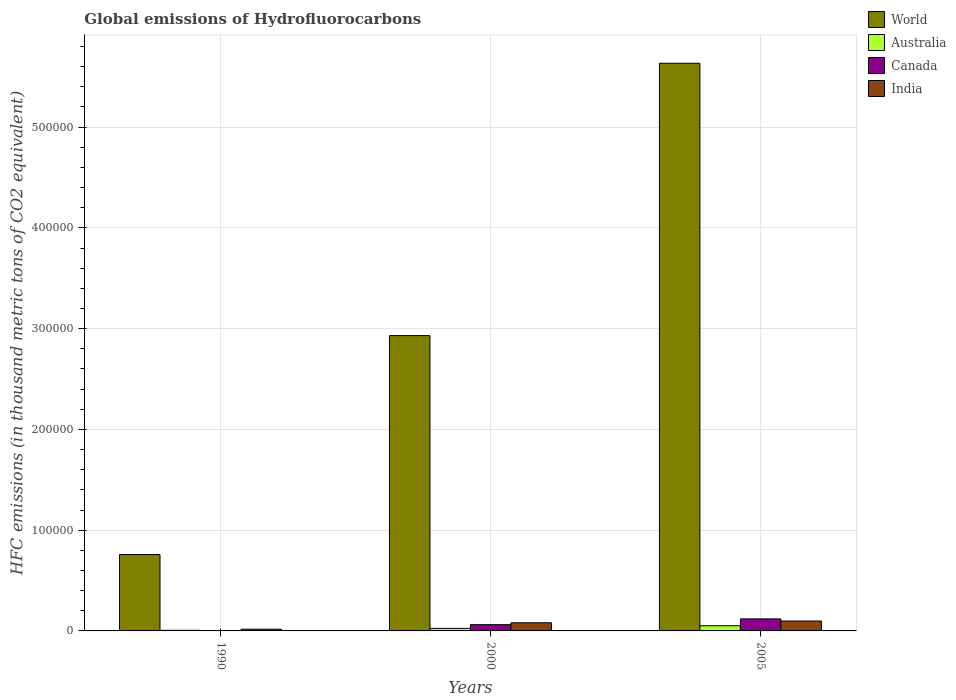How many different coloured bars are there?
Ensure brevity in your answer.  4. Are the number of bars on each tick of the X-axis equal?
Your answer should be very brief. Yes. What is the label of the 1st group of bars from the left?
Your answer should be very brief. 1990. In how many cases, is the number of bars for a given year not equal to the number of legend labels?
Give a very brief answer. 0. What is the global emissions of Hydrofluorocarbons in Canada in 1990?
Your answer should be very brief. 418.5. Across all years, what is the maximum global emissions of Hydrofluorocarbons in World?
Your answer should be compact. 5.63e+05. Across all years, what is the minimum global emissions of Hydrofluorocarbons in Canada?
Your answer should be very brief. 418.5. What is the total global emissions of Hydrofluorocarbons in World in the graph?
Ensure brevity in your answer.  9.32e+05. What is the difference between the global emissions of Hydrofluorocarbons in World in 1990 and that in 2005?
Ensure brevity in your answer.  -4.88e+05. What is the difference between the global emissions of Hydrofluorocarbons in India in 2000 and the global emissions of Hydrofluorocarbons in Canada in 2005?
Provide a short and direct response. -3821.2. What is the average global emissions of Hydrofluorocarbons in Canada per year?
Make the answer very short. 6183.23. In the year 1990, what is the difference between the global emissions of Hydrofluorocarbons in World and global emissions of Hydrofluorocarbons in Australia?
Provide a short and direct response. 7.52e+04. What is the ratio of the global emissions of Hydrofluorocarbons in India in 2000 to that in 2005?
Your response must be concise. 0.82. Is the global emissions of Hydrofluorocarbons in India in 2000 less than that in 2005?
Make the answer very short. Yes. Is the difference between the global emissions of Hydrofluorocarbons in World in 2000 and 2005 greater than the difference between the global emissions of Hydrofluorocarbons in Australia in 2000 and 2005?
Give a very brief answer. No. What is the difference between the highest and the second highest global emissions of Hydrofluorocarbons in India?
Offer a very short reply. 1738. What is the difference between the highest and the lowest global emissions of Hydrofluorocarbons in Australia?
Keep it short and to the point. 4533.1. In how many years, is the global emissions of Hydrofluorocarbons in Canada greater than the average global emissions of Hydrofluorocarbons in Canada taken over all years?
Your answer should be compact. 2. Are all the bars in the graph horizontal?
Your answer should be very brief. No. How many years are there in the graph?
Your answer should be compact. 3. Are the values on the major ticks of Y-axis written in scientific E-notation?
Provide a succinct answer. No. Does the graph contain any zero values?
Give a very brief answer. No. Does the graph contain grids?
Your answer should be very brief. Yes. How are the legend labels stacked?
Offer a terse response. Vertical. What is the title of the graph?
Make the answer very short. Global emissions of Hydrofluorocarbons. What is the label or title of the X-axis?
Give a very brief answer. Years. What is the label or title of the Y-axis?
Ensure brevity in your answer.  HFC emissions (in thousand metric tons of CO2 equivalent). What is the HFC emissions (in thousand metric tons of CO2 equivalent) of World in 1990?
Offer a terse response. 7.58e+04. What is the HFC emissions (in thousand metric tons of CO2 equivalent) in Australia in 1990?
Your answer should be compact. 612.5. What is the HFC emissions (in thousand metric tons of CO2 equivalent) in Canada in 1990?
Ensure brevity in your answer.  418.5. What is the HFC emissions (in thousand metric tons of CO2 equivalent) of India in 1990?
Provide a succinct answer. 1702.1. What is the HFC emissions (in thousand metric tons of CO2 equivalent) in World in 2000?
Offer a very short reply. 2.93e+05. What is the HFC emissions (in thousand metric tons of CO2 equivalent) of Australia in 2000?
Ensure brevity in your answer.  2545.7. What is the HFC emissions (in thousand metric tons of CO2 equivalent) of Canada in 2000?
Your answer should be compact. 6202.8. What is the HFC emissions (in thousand metric tons of CO2 equivalent) of India in 2000?
Offer a terse response. 8107.2. What is the HFC emissions (in thousand metric tons of CO2 equivalent) in World in 2005?
Your response must be concise. 5.63e+05. What is the HFC emissions (in thousand metric tons of CO2 equivalent) of Australia in 2005?
Your answer should be very brief. 5145.6. What is the HFC emissions (in thousand metric tons of CO2 equivalent) in Canada in 2005?
Your answer should be compact. 1.19e+04. What is the HFC emissions (in thousand metric tons of CO2 equivalent) of India in 2005?
Make the answer very short. 9845.2. Across all years, what is the maximum HFC emissions (in thousand metric tons of CO2 equivalent) of World?
Your answer should be compact. 5.63e+05. Across all years, what is the maximum HFC emissions (in thousand metric tons of CO2 equivalent) of Australia?
Provide a succinct answer. 5145.6. Across all years, what is the maximum HFC emissions (in thousand metric tons of CO2 equivalent) in Canada?
Make the answer very short. 1.19e+04. Across all years, what is the maximum HFC emissions (in thousand metric tons of CO2 equivalent) in India?
Make the answer very short. 9845.2. Across all years, what is the minimum HFC emissions (in thousand metric tons of CO2 equivalent) in World?
Your answer should be compact. 7.58e+04. Across all years, what is the minimum HFC emissions (in thousand metric tons of CO2 equivalent) of Australia?
Offer a very short reply. 612.5. Across all years, what is the minimum HFC emissions (in thousand metric tons of CO2 equivalent) of Canada?
Offer a very short reply. 418.5. Across all years, what is the minimum HFC emissions (in thousand metric tons of CO2 equivalent) of India?
Provide a succinct answer. 1702.1. What is the total HFC emissions (in thousand metric tons of CO2 equivalent) of World in the graph?
Offer a terse response. 9.32e+05. What is the total HFC emissions (in thousand metric tons of CO2 equivalent) in Australia in the graph?
Provide a succinct answer. 8303.8. What is the total HFC emissions (in thousand metric tons of CO2 equivalent) in Canada in the graph?
Keep it short and to the point. 1.85e+04. What is the total HFC emissions (in thousand metric tons of CO2 equivalent) in India in the graph?
Provide a succinct answer. 1.97e+04. What is the difference between the HFC emissions (in thousand metric tons of CO2 equivalent) in World in 1990 and that in 2000?
Give a very brief answer. -2.17e+05. What is the difference between the HFC emissions (in thousand metric tons of CO2 equivalent) of Australia in 1990 and that in 2000?
Offer a terse response. -1933.2. What is the difference between the HFC emissions (in thousand metric tons of CO2 equivalent) of Canada in 1990 and that in 2000?
Keep it short and to the point. -5784.3. What is the difference between the HFC emissions (in thousand metric tons of CO2 equivalent) in India in 1990 and that in 2000?
Give a very brief answer. -6405.1. What is the difference between the HFC emissions (in thousand metric tons of CO2 equivalent) in World in 1990 and that in 2005?
Give a very brief answer. -4.88e+05. What is the difference between the HFC emissions (in thousand metric tons of CO2 equivalent) of Australia in 1990 and that in 2005?
Make the answer very short. -4533.1. What is the difference between the HFC emissions (in thousand metric tons of CO2 equivalent) of Canada in 1990 and that in 2005?
Keep it short and to the point. -1.15e+04. What is the difference between the HFC emissions (in thousand metric tons of CO2 equivalent) in India in 1990 and that in 2005?
Keep it short and to the point. -8143.1. What is the difference between the HFC emissions (in thousand metric tons of CO2 equivalent) of World in 2000 and that in 2005?
Your response must be concise. -2.70e+05. What is the difference between the HFC emissions (in thousand metric tons of CO2 equivalent) in Australia in 2000 and that in 2005?
Give a very brief answer. -2599.9. What is the difference between the HFC emissions (in thousand metric tons of CO2 equivalent) in Canada in 2000 and that in 2005?
Keep it short and to the point. -5725.6. What is the difference between the HFC emissions (in thousand metric tons of CO2 equivalent) of India in 2000 and that in 2005?
Offer a very short reply. -1738. What is the difference between the HFC emissions (in thousand metric tons of CO2 equivalent) of World in 1990 and the HFC emissions (in thousand metric tons of CO2 equivalent) of Australia in 2000?
Your response must be concise. 7.33e+04. What is the difference between the HFC emissions (in thousand metric tons of CO2 equivalent) in World in 1990 and the HFC emissions (in thousand metric tons of CO2 equivalent) in Canada in 2000?
Offer a terse response. 6.96e+04. What is the difference between the HFC emissions (in thousand metric tons of CO2 equivalent) in World in 1990 and the HFC emissions (in thousand metric tons of CO2 equivalent) in India in 2000?
Offer a terse response. 6.77e+04. What is the difference between the HFC emissions (in thousand metric tons of CO2 equivalent) in Australia in 1990 and the HFC emissions (in thousand metric tons of CO2 equivalent) in Canada in 2000?
Your answer should be very brief. -5590.3. What is the difference between the HFC emissions (in thousand metric tons of CO2 equivalent) of Australia in 1990 and the HFC emissions (in thousand metric tons of CO2 equivalent) of India in 2000?
Keep it short and to the point. -7494.7. What is the difference between the HFC emissions (in thousand metric tons of CO2 equivalent) in Canada in 1990 and the HFC emissions (in thousand metric tons of CO2 equivalent) in India in 2000?
Make the answer very short. -7688.7. What is the difference between the HFC emissions (in thousand metric tons of CO2 equivalent) in World in 1990 and the HFC emissions (in thousand metric tons of CO2 equivalent) in Australia in 2005?
Keep it short and to the point. 7.07e+04. What is the difference between the HFC emissions (in thousand metric tons of CO2 equivalent) of World in 1990 and the HFC emissions (in thousand metric tons of CO2 equivalent) of Canada in 2005?
Make the answer very short. 6.39e+04. What is the difference between the HFC emissions (in thousand metric tons of CO2 equivalent) of World in 1990 and the HFC emissions (in thousand metric tons of CO2 equivalent) of India in 2005?
Provide a short and direct response. 6.60e+04. What is the difference between the HFC emissions (in thousand metric tons of CO2 equivalent) of Australia in 1990 and the HFC emissions (in thousand metric tons of CO2 equivalent) of Canada in 2005?
Your answer should be very brief. -1.13e+04. What is the difference between the HFC emissions (in thousand metric tons of CO2 equivalent) in Australia in 1990 and the HFC emissions (in thousand metric tons of CO2 equivalent) in India in 2005?
Ensure brevity in your answer.  -9232.7. What is the difference between the HFC emissions (in thousand metric tons of CO2 equivalent) of Canada in 1990 and the HFC emissions (in thousand metric tons of CO2 equivalent) of India in 2005?
Your response must be concise. -9426.7. What is the difference between the HFC emissions (in thousand metric tons of CO2 equivalent) of World in 2000 and the HFC emissions (in thousand metric tons of CO2 equivalent) of Australia in 2005?
Give a very brief answer. 2.88e+05. What is the difference between the HFC emissions (in thousand metric tons of CO2 equivalent) in World in 2000 and the HFC emissions (in thousand metric tons of CO2 equivalent) in Canada in 2005?
Make the answer very short. 2.81e+05. What is the difference between the HFC emissions (in thousand metric tons of CO2 equivalent) in World in 2000 and the HFC emissions (in thousand metric tons of CO2 equivalent) in India in 2005?
Ensure brevity in your answer.  2.83e+05. What is the difference between the HFC emissions (in thousand metric tons of CO2 equivalent) in Australia in 2000 and the HFC emissions (in thousand metric tons of CO2 equivalent) in Canada in 2005?
Your answer should be very brief. -9382.7. What is the difference between the HFC emissions (in thousand metric tons of CO2 equivalent) of Australia in 2000 and the HFC emissions (in thousand metric tons of CO2 equivalent) of India in 2005?
Offer a very short reply. -7299.5. What is the difference between the HFC emissions (in thousand metric tons of CO2 equivalent) of Canada in 2000 and the HFC emissions (in thousand metric tons of CO2 equivalent) of India in 2005?
Your answer should be compact. -3642.4. What is the average HFC emissions (in thousand metric tons of CO2 equivalent) in World per year?
Your answer should be compact. 3.11e+05. What is the average HFC emissions (in thousand metric tons of CO2 equivalent) of Australia per year?
Make the answer very short. 2767.93. What is the average HFC emissions (in thousand metric tons of CO2 equivalent) of Canada per year?
Keep it short and to the point. 6183.23. What is the average HFC emissions (in thousand metric tons of CO2 equivalent) in India per year?
Offer a very short reply. 6551.5. In the year 1990, what is the difference between the HFC emissions (in thousand metric tons of CO2 equivalent) in World and HFC emissions (in thousand metric tons of CO2 equivalent) in Australia?
Ensure brevity in your answer.  7.52e+04. In the year 1990, what is the difference between the HFC emissions (in thousand metric tons of CO2 equivalent) of World and HFC emissions (in thousand metric tons of CO2 equivalent) of Canada?
Ensure brevity in your answer.  7.54e+04. In the year 1990, what is the difference between the HFC emissions (in thousand metric tons of CO2 equivalent) of World and HFC emissions (in thousand metric tons of CO2 equivalent) of India?
Keep it short and to the point. 7.41e+04. In the year 1990, what is the difference between the HFC emissions (in thousand metric tons of CO2 equivalent) of Australia and HFC emissions (in thousand metric tons of CO2 equivalent) of Canada?
Make the answer very short. 194. In the year 1990, what is the difference between the HFC emissions (in thousand metric tons of CO2 equivalent) in Australia and HFC emissions (in thousand metric tons of CO2 equivalent) in India?
Your answer should be compact. -1089.6. In the year 1990, what is the difference between the HFC emissions (in thousand metric tons of CO2 equivalent) in Canada and HFC emissions (in thousand metric tons of CO2 equivalent) in India?
Make the answer very short. -1283.6. In the year 2000, what is the difference between the HFC emissions (in thousand metric tons of CO2 equivalent) in World and HFC emissions (in thousand metric tons of CO2 equivalent) in Australia?
Give a very brief answer. 2.91e+05. In the year 2000, what is the difference between the HFC emissions (in thousand metric tons of CO2 equivalent) of World and HFC emissions (in thousand metric tons of CO2 equivalent) of Canada?
Your response must be concise. 2.87e+05. In the year 2000, what is the difference between the HFC emissions (in thousand metric tons of CO2 equivalent) of World and HFC emissions (in thousand metric tons of CO2 equivalent) of India?
Your answer should be compact. 2.85e+05. In the year 2000, what is the difference between the HFC emissions (in thousand metric tons of CO2 equivalent) of Australia and HFC emissions (in thousand metric tons of CO2 equivalent) of Canada?
Your answer should be very brief. -3657.1. In the year 2000, what is the difference between the HFC emissions (in thousand metric tons of CO2 equivalent) in Australia and HFC emissions (in thousand metric tons of CO2 equivalent) in India?
Give a very brief answer. -5561.5. In the year 2000, what is the difference between the HFC emissions (in thousand metric tons of CO2 equivalent) of Canada and HFC emissions (in thousand metric tons of CO2 equivalent) of India?
Provide a succinct answer. -1904.4. In the year 2005, what is the difference between the HFC emissions (in thousand metric tons of CO2 equivalent) in World and HFC emissions (in thousand metric tons of CO2 equivalent) in Australia?
Keep it short and to the point. 5.58e+05. In the year 2005, what is the difference between the HFC emissions (in thousand metric tons of CO2 equivalent) of World and HFC emissions (in thousand metric tons of CO2 equivalent) of Canada?
Provide a short and direct response. 5.51e+05. In the year 2005, what is the difference between the HFC emissions (in thousand metric tons of CO2 equivalent) of World and HFC emissions (in thousand metric tons of CO2 equivalent) of India?
Make the answer very short. 5.54e+05. In the year 2005, what is the difference between the HFC emissions (in thousand metric tons of CO2 equivalent) of Australia and HFC emissions (in thousand metric tons of CO2 equivalent) of Canada?
Ensure brevity in your answer.  -6782.8. In the year 2005, what is the difference between the HFC emissions (in thousand metric tons of CO2 equivalent) of Australia and HFC emissions (in thousand metric tons of CO2 equivalent) of India?
Your answer should be compact. -4699.6. In the year 2005, what is the difference between the HFC emissions (in thousand metric tons of CO2 equivalent) in Canada and HFC emissions (in thousand metric tons of CO2 equivalent) in India?
Offer a very short reply. 2083.2. What is the ratio of the HFC emissions (in thousand metric tons of CO2 equivalent) of World in 1990 to that in 2000?
Give a very brief answer. 0.26. What is the ratio of the HFC emissions (in thousand metric tons of CO2 equivalent) of Australia in 1990 to that in 2000?
Your response must be concise. 0.24. What is the ratio of the HFC emissions (in thousand metric tons of CO2 equivalent) in Canada in 1990 to that in 2000?
Offer a very short reply. 0.07. What is the ratio of the HFC emissions (in thousand metric tons of CO2 equivalent) of India in 1990 to that in 2000?
Your response must be concise. 0.21. What is the ratio of the HFC emissions (in thousand metric tons of CO2 equivalent) in World in 1990 to that in 2005?
Make the answer very short. 0.13. What is the ratio of the HFC emissions (in thousand metric tons of CO2 equivalent) in Australia in 1990 to that in 2005?
Offer a terse response. 0.12. What is the ratio of the HFC emissions (in thousand metric tons of CO2 equivalent) in Canada in 1990 to that in 2005?
Make the answer very short. 0.04. What is the ratio of the HFC emissions (in thousand metric tons of CO2 equivalent) of India in 1990 to that in 2005?
Offer a very short reply. 0.17. What is the ratio of the HFC emissions (in thousand metric tons of CO2 equivalent) in World in 2000 to that in 2005?
Your response must be concise. 0.52. What is the ratio of the HFC emissions (in thousand metric tons of CO2 equivalent) of Australia in 2000 to that in 2005?
Your answer should be compact. 0.49. What is the ratio of the HFC emissions (in thousand metric tons of CO2 equivalent) in Canada in 2000 to that in 2005?
Your response must be concise. 0.52. What is the ratio of the HFC emissions (in thousand metric tons of CO2 equivalent) in India in 2000 to that in 2005?
Keep it short and to the point. 0.82. What is the difference between the highest and the second highest HFC emissions (in thousand metric tons of CO2 equivalent) in World?
Ensure brevity in your answer.  2.70e+05. What is the difference between the highest and the second highest HFC emissions (in thousand metric tons of CO2 equivalent) of Australia?
Offer a terse response. 2599.9. What is the difference between the highest and the second highest HFC emissions (in thousand metric tons of CO2 equivalent) in Canada?
Your response must be concise. 5725.6. What is the difference between the highest and the second highest HFC emissions (in thousand metric tons of CO2 equivalent) in India?
Provide a short and direct response. 1738. What is the difference between the highest and the lowest HFC emissions (in thousand metric tons of CO2 equivalent) in World?
Provide a short and direct response. 4.88e+05. What is the difference between the highest and the lowest HFC emissions (in thousand metric tons of CO2 equivalent) in Australia?
Offer a terse response. 4533.1. What is the difference between the highest and the lowest HFC emissions (in thousand metric tons of CO2 equivalent) in Canada?
Your answer should be compact. 1.15e+04. What is the difference between the highest and the lowest HFC emissions (in thousand metric tons of CO2 equivalent) of India?
Keep it short and to the point. 8143.1. 